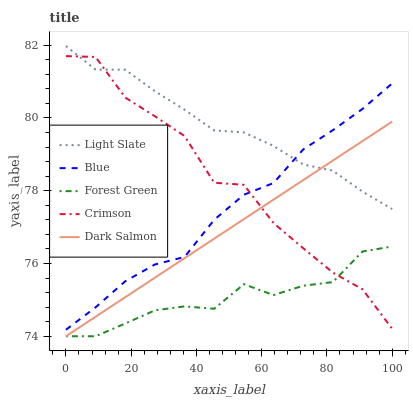Does Forest Green have the minimum area under the curve?
Answer yes or no. Yes. Does Light Slate have the maximum area under the curve?
Answer yes or no. Yes. Does Blue have the minimum area under the curve?
Answer yes or no. No. Does Blue have the maximum area under the curve?
Answer yes or no. No. Is Dark Salmon the smoothest?
Answer yes or no. Yes. Is Crimson the roughest?
Answer yes or no. Yes. Is Blue the smoothest?
Answer yes or no. No. Is Blue the roughest?
Answer yes or no. No. Does Forest Green have the lowest value?
Answer yes or no. Yes. Does Blue have the lowest value?
Answer yes or no. No. Does Light Slate have the highest value?
Answer yes or no. Yes. Does Blue have the highest value?
Answer yes or no. No. Is Forest Green less than Blue?
Answer yes or no. Yes. Is Blue greater than Forest Green?
Answer yes or no. Yes. Does Light Slate intersect Blue?
Answer yes or no. Yes. Is Light Slate less than Blue?
Answer yes or no. No. Is Light Slate greater than Blue?
Answer yes or no. No. Does Forest Green intersect Blue?
Answer yes or no. No. 